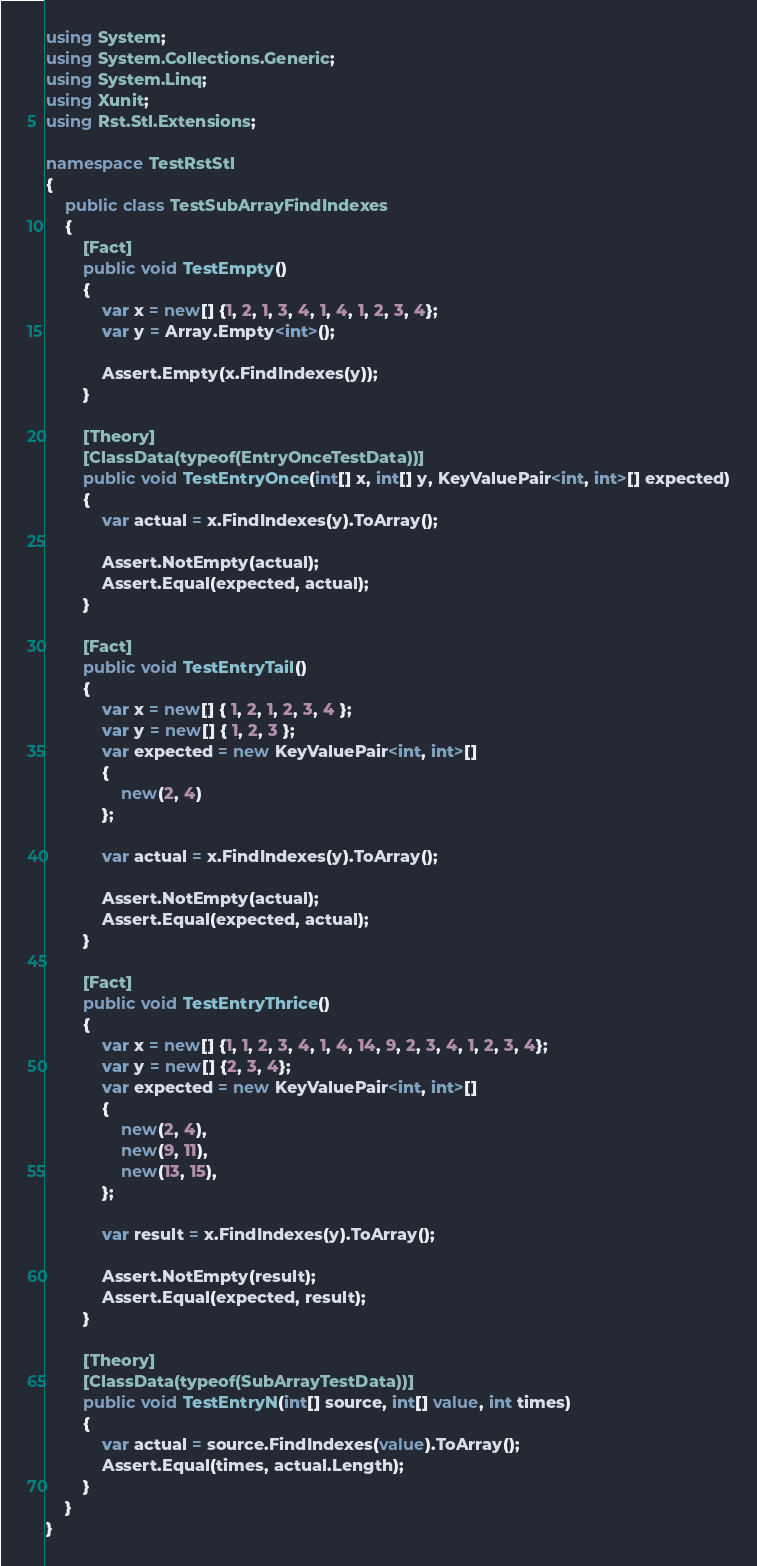<code> <loc_0><loc_0><loc_500><loc_500><_C#_>using System;
using System.Collections.Generic;
using System.Linq;
using Xunit;
using Rst.Stl.Extensions;

namespace TestRstStl
{
    public class TestSubArrayFindIndexes
    {
        [Fact]
        public void TestEmpty()
        {
            var x = new[] {1, 2, 1, 3, 4, 1, 4, 1, 2, 3, 4};
            var y = Array.Empty<int>();
            
            Assert.Empty(x.FindIndexes(y));
        }
        
        [Theory]
        [ClassData(typeof(EntryOnceTestData))]
        public void TestEntryOnce(int[] x, int[] y, KeyValuePair<int, int>[] expected)
        {
            var actual = x.FindIndexes(y).ToArray();
            
            Assert.NotEmpty(actual);
            Assert.Equal(expected, actual);
        }
        
        [Fact]
        public void TestEntryTail()
        {
            var x = new[] { 1, 2, 1, 2, 3, 4 };
            var y = new[] { 1, 2, 3 };
            var expected = new KeyValuePair<int, int>[]
            {
                new(2, 4)
            };
            
            var actual = x.FindIndexes(y).ToArray();
            
            Assert.NotEmpty(actual);
            Assert.Equal(expected, actual);
        }
        
        [Fact]
        public void TestEntryThrice()
        {
            var x = new[] {1, 1, 2, 3, 4, 1, 4, 14, 9, 2, 3, 4, 1, 2, 3, 4};
            var y = new[] {2, 3, 4};
            var expected = new KeyValuePair<int, int>[]
            {
                new(2, 4),
                new(9, 11),
                new(13, 15),
            };
            
            var result = x.FindIndexes(y).ToArray();
            
            Assert.NotEmpty(result);
            Assert.Equal(expected, result);
        }
        
        [Theory]
        [ClassData(typeof(SubArrayTestData))]
        public void TestEntryN(int[] source, int[] value, int times)
        {
            var actual = source.FindIndexes(value).ToArray();
            Assert.Equal(times, actual.Length);
        }
    }
}</code> 